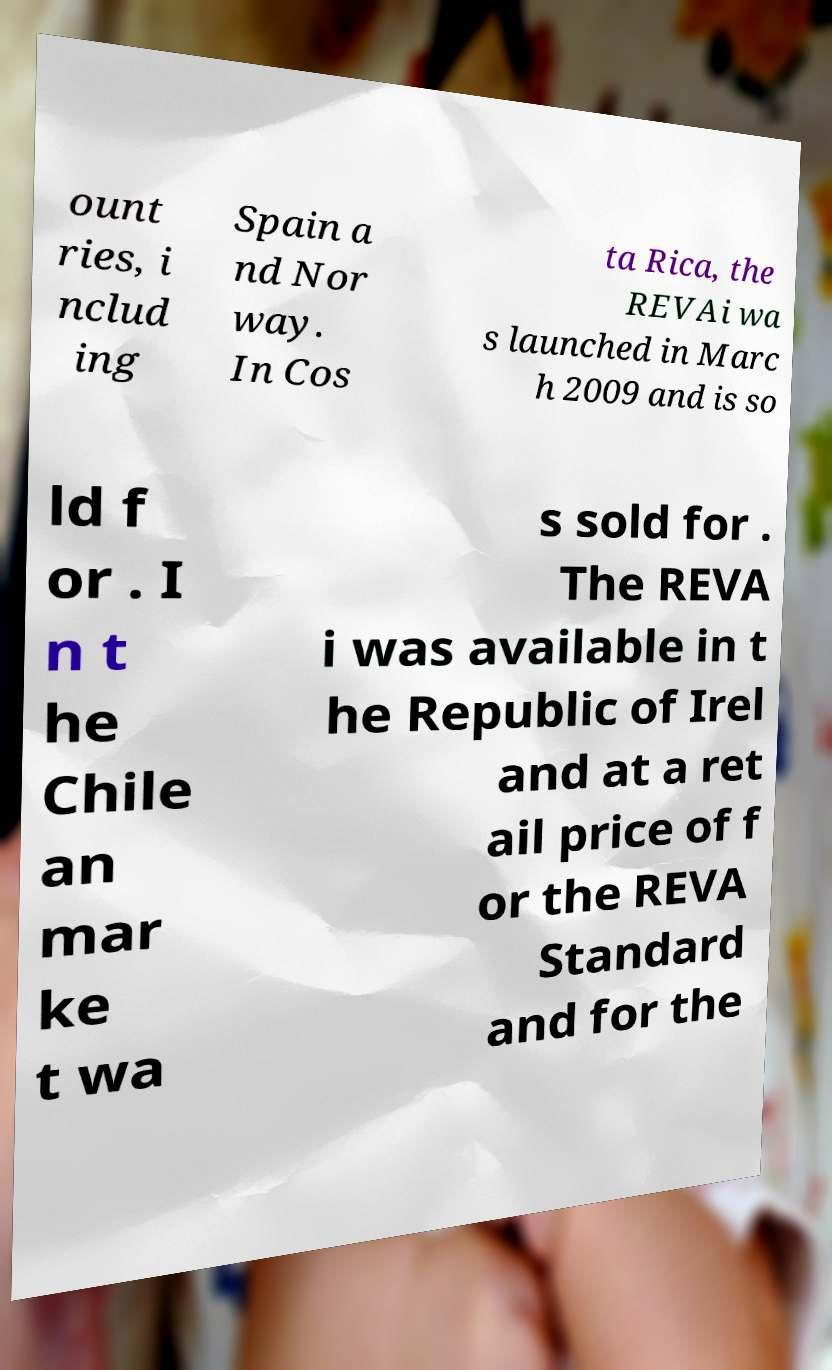Please identify and transcribe the text found in this image. ount ries, i nclud ing Spain a nd Nor way. In Cos ta Rica, the REVAi wa s launched in Marc h 2009 and is so ld f or . I n t he Chile an mar ke t wa s sold for . The REVA i was available in t he Republic of Irel and at a ret ail price of f or the REVA Standard and for the 